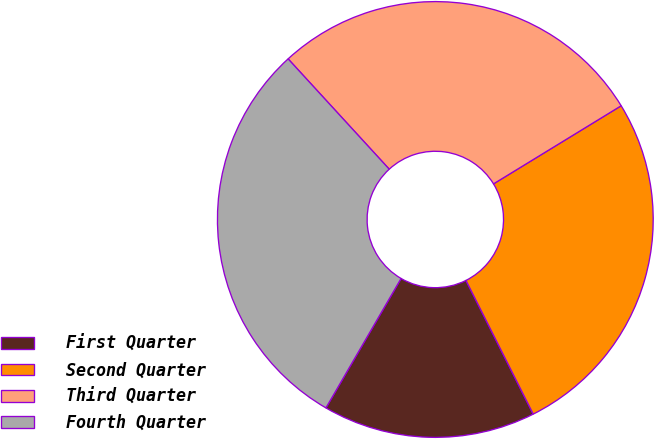Convert chart to OTSL. <chart><loc_0><loc_0><loc_500><loc_500><pie_chart><fcel>First Quarter<fcel>Second Quarter<fcel>Third Quarter<fcel>Fourth Quarter<nl><fcel>15.79%<fcel>26.32%<fcel>28.07%<fcel>29.82%<nl></chart> 